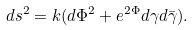<formula> <loc_0><loc_0><loc_500><loc_500>d s ^ { 2 } = k ( d { \Phi } ^ { 2 } + e ^ { 2 { \Phi } } { d { \gamma } } { d { \bar { \gamma } } } ) .</formula> 